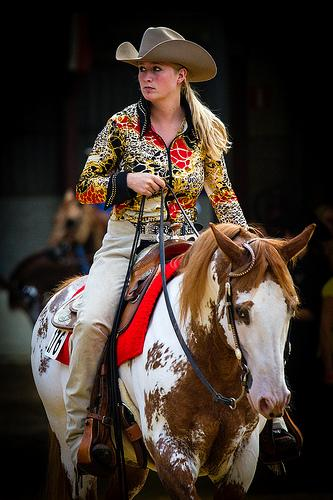Provide a concise description of the image focusing on the woman and the horse. A blonde woman in a beige hat and multicolored jacket rides a white and brown horse. Mention the primary action and the two characters involved in the image. A blond woman wearing a cowboy hat is riding on a white and brown horse. Discuss the main subject in the image and their actions in a short phrase. Cowgirl in vibrant attire saddled upon her brown and white horse. Describe the woman's clothing and the horse's features in the image. The woman has a beige cowboy hat, yellow, red, and black jacket, and white pants; the horse is white and brown with a pink nose. What is the most noticeable aspect of the woman's appearance in the image? The woman is noticeable for her tan hat, blonde hair, and yellow, red, and black jacket. Write a simple description of the main subjects of the image. A woman with a cowboy hat is sitting on a brown and white horse. Provide a creative description of the scene depicted in the image. A spirited cowgirl with golden locks and a vibrant attire confidently rides her trusty, two-toned steed. What are the main colors found in the woman's outfit and the horse's appearance? The woman's outfit includes beige, yellow, red, black, and white, while the horse is white and brown with a touch of pink. Provide a brief description of the central figure in the image. A blond woman in a cowboy hat and bright colored shirt is riding a white and brown horse. Summarize the key elements of the image in a single sentence. A woman wearing a beige hat and colorful jacket is sitting on a brown and white horse. 